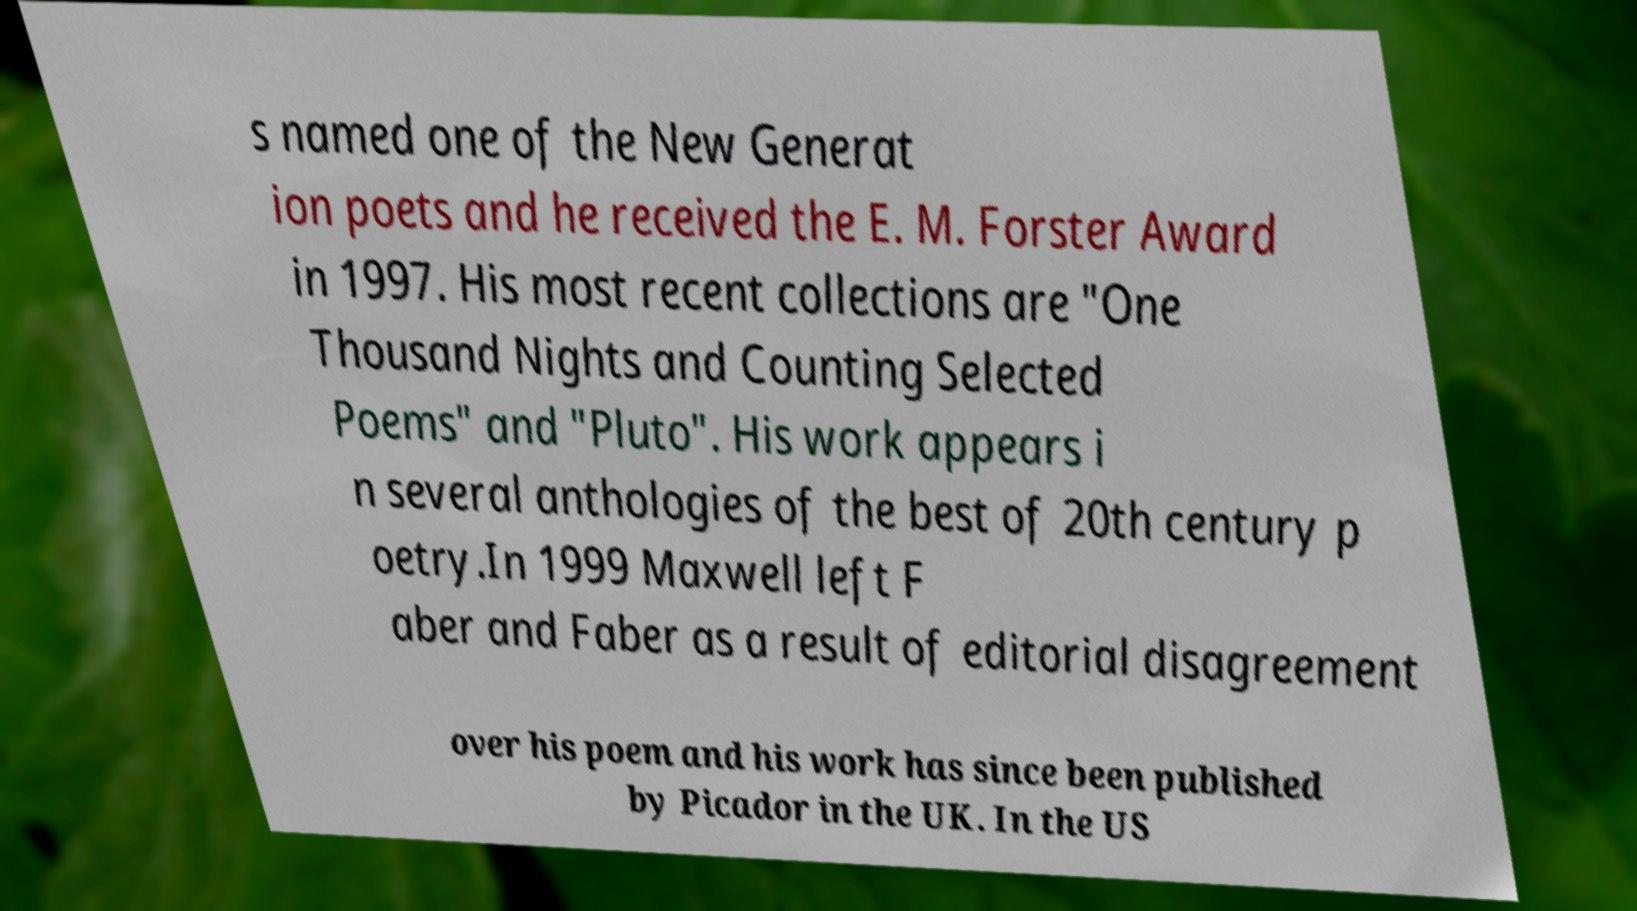Can you accurately transcribe the text from the provided image for me? s named one of the New Generat ion poets and he received the E. M. Forster Award in 1997. His most recent collections are "One Thousand Nights and Counting Selected Poems" and "Pluto". His work appears i n several anthologies of the best of 20th century p oetry.In 1999 Maxwell left F aber and Faber as a result of editorial disagreement over his poem and his work has since been published by Picador in the UK. In the US 